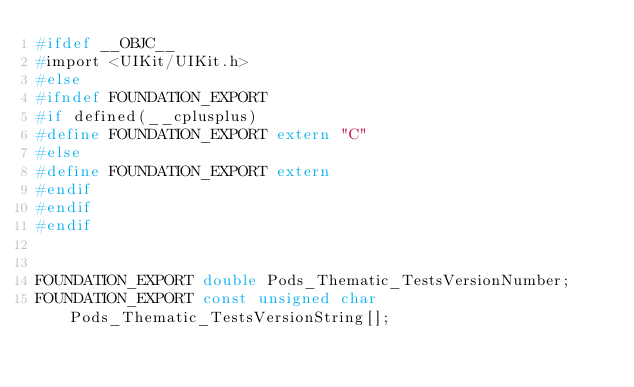<code> <loc_0><loc_0><loc_500><loc_500><_C_>#ifdef __OBJC__
#import <UIKit/UIKit.h>
#else
#ifndef FOUNDATION_EXPORT
#if defined(__cplusplus)
#define FOUNDATION_EXPORT extern "C"
#else
#define FOUNDATION_EXPORT extern
#endif
#endif
#endif


FOUNDATION_EXPORT double Pods_Thematic_TestsVersionNumber;
FOUNDATION_EXPORT const unsigned char Pods_Thematic_TestsVersionString[];

</code> 